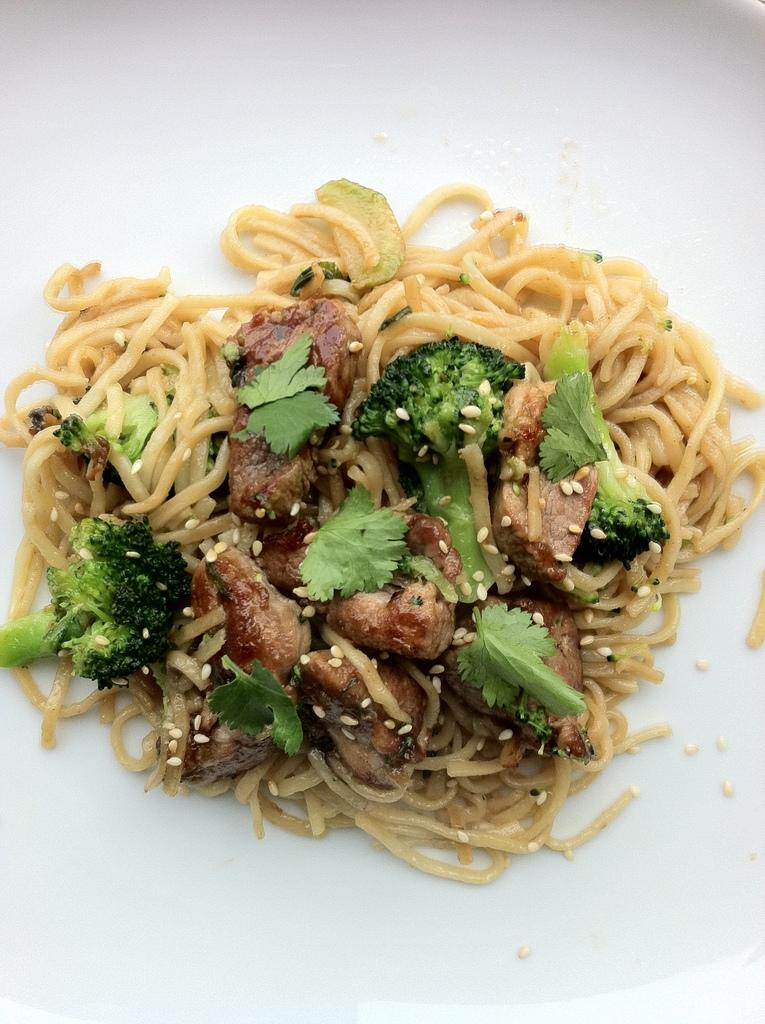What types of items can be seen in the image? There are food items in the image. What is the color of the surface on which the food items are placed? The surface on which the food items are placed is white-colored. What type of wool is used to make the cushion in the image? There is no cushion present in the image, so it is not possible to determine the type of wool used. 